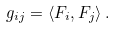Convert formula to latex. <formula><loc_0><loc_0><loc_500><loc_500>g _ { i j } = \langle F _ { i } , F _ { j } \rangle \, .</formula> 